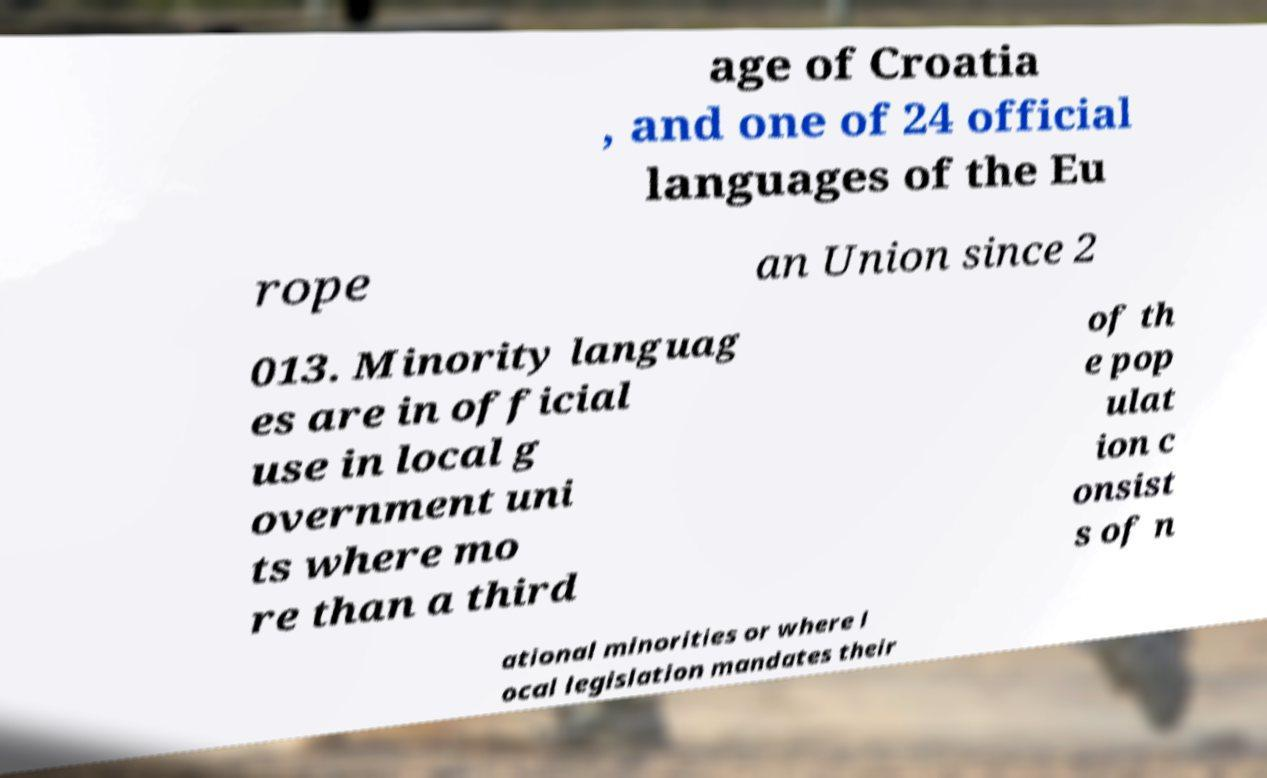I need the written content from this picture converted into text. Can you do that? age of Croatia , and one of 24 official languages of the Eu rope an Union since 2 013. Minority languag es are in official use in local g overnment uni ts where mo re than a third of th e pop ulat ion c onsist s of n ational minorities or where l ocal legislation mandates their 